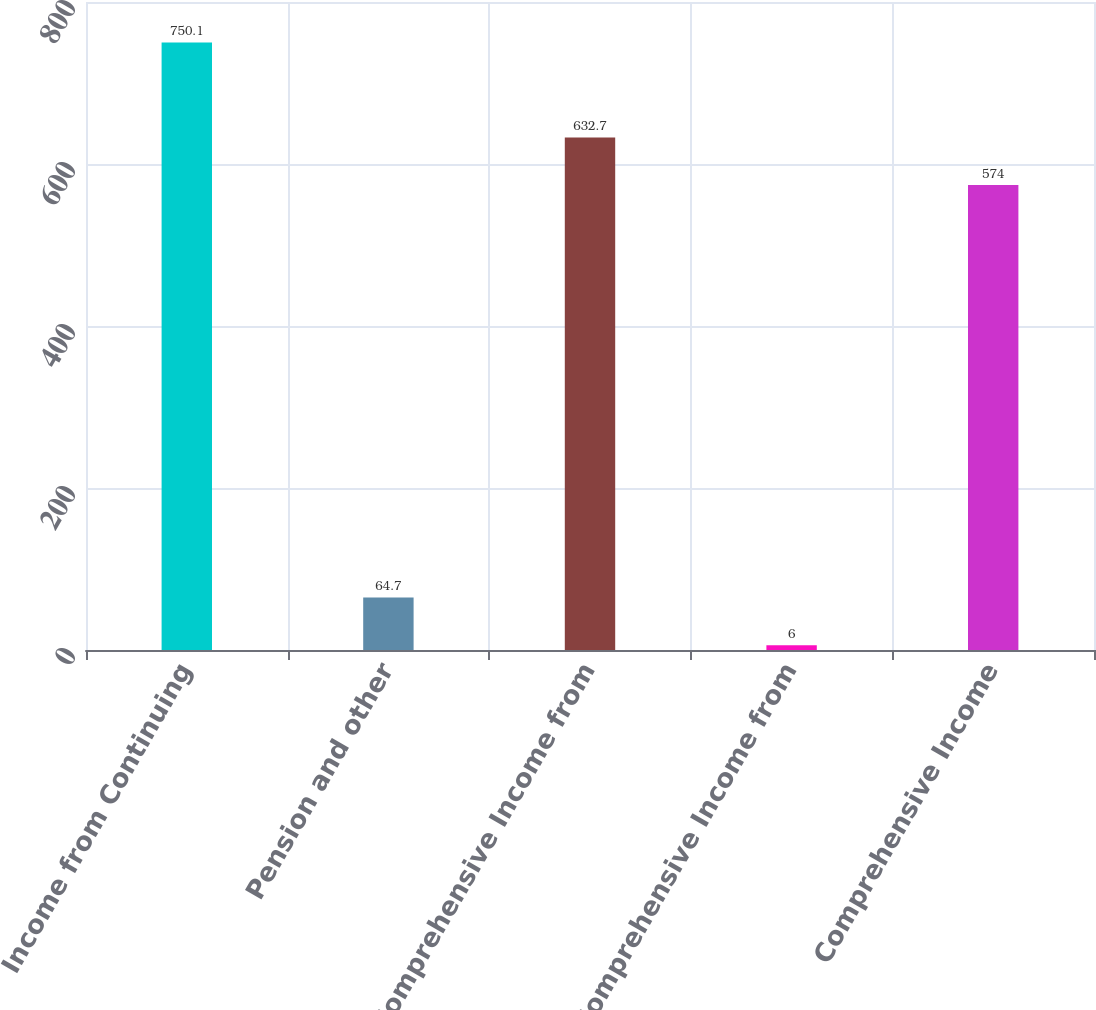<chart> <loc_0><loc_0><loc_500><loc_500><bar_chart><fcel>Income from Continuing<fcel>Pension and other<fcel>Comprehensive Income from<fcel>Less Comprehensive Income from<fcel>Comprehensive Income<nl><fcel>750.1<fcel>64.7<fcel>632.7<fcel>6<fcel>574<nl></chart> 